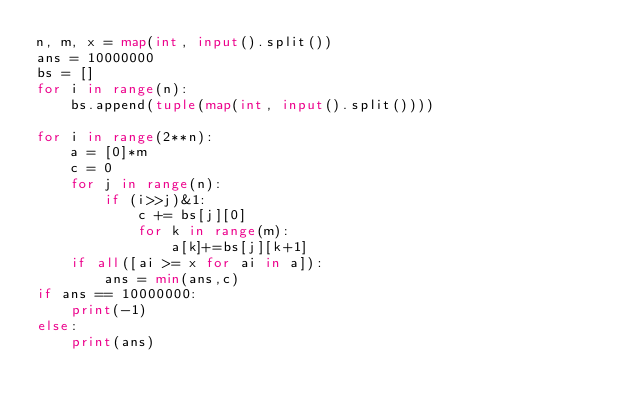<code> <loc_0><loc_0><loc_500><loc_500><_Python_>n, m, x = map(int, input().split())
ans = 10000000
bs = []
for i in range(n):
    bs.append(tuple(map(int, input().split())))

for i in range(2**n):
    a = [0]*m
    c = 0
    for j in range(n):
        if (i>>j)&1:
            c += bs[j][0]
            for k in range(m):
                a[k]+=bs[j][k+1]
    if all([ai >= x for ai in a]):
        ans = min(ans,c)
if ans == 10000000:
    print(-1)
else:
    print(ans)</code> 